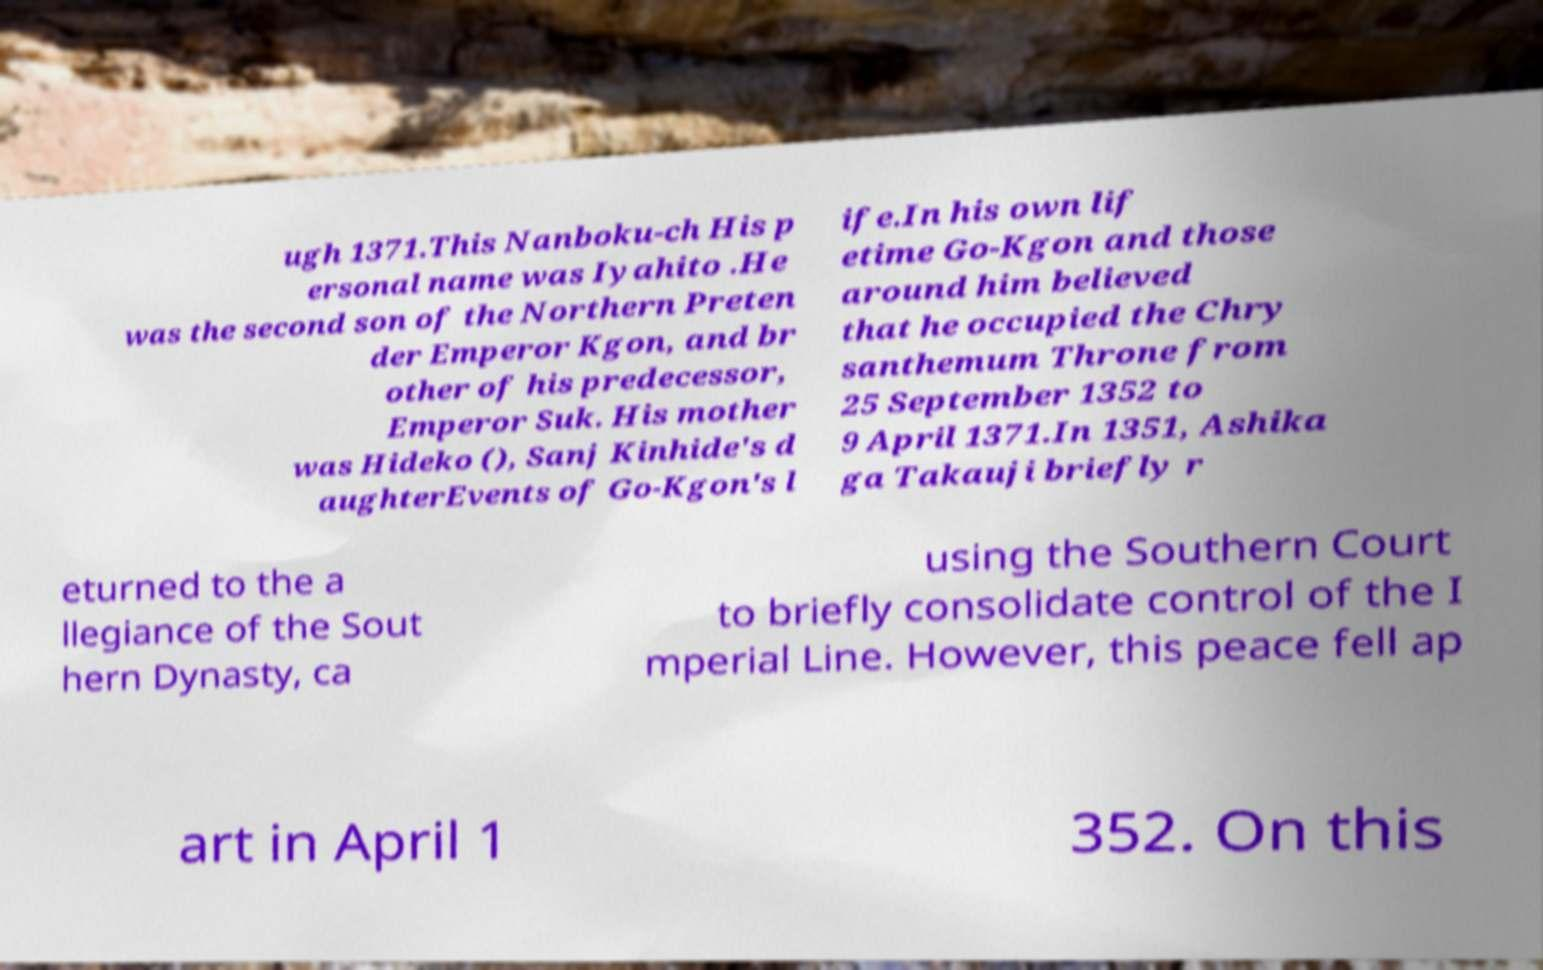Could you extract and type out the text from this image? ugh 1371.This Nanboku-ch His p ersonal name was Iyahito .He was the second son of the Northern Preten der Emperor Kgon, and br other of his predecessor, Emperor Suk. His mother was Hideko (), Sanj Kinhide's d aughterEvents of Go-Kgon's l ife.In his own lif etime Go-Kgon and those around him believed that he occupied the Chry santhemum Throne from 25 September 1352 to 9 April 1371.In 1351, Ashika ga Takauji briefly r eturned to the a llegiance of the Sout hern Dynasty, ca using the Southern Court to briefly consolidate control of the I mperial Line. However, this peace fell ap art in April 1 352. On this 